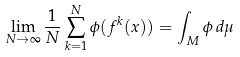Convert formula to latex. <formula><loc_0><loc_0><loc_500><loc_500>\lim _ { N \to \infty } \frac { 1 } { N } \sum _ { k = 1 } ^ { N } \phi ( f ^ { k } ( x ) ) = \int _ { M } \phi \, d \mu</formula> 